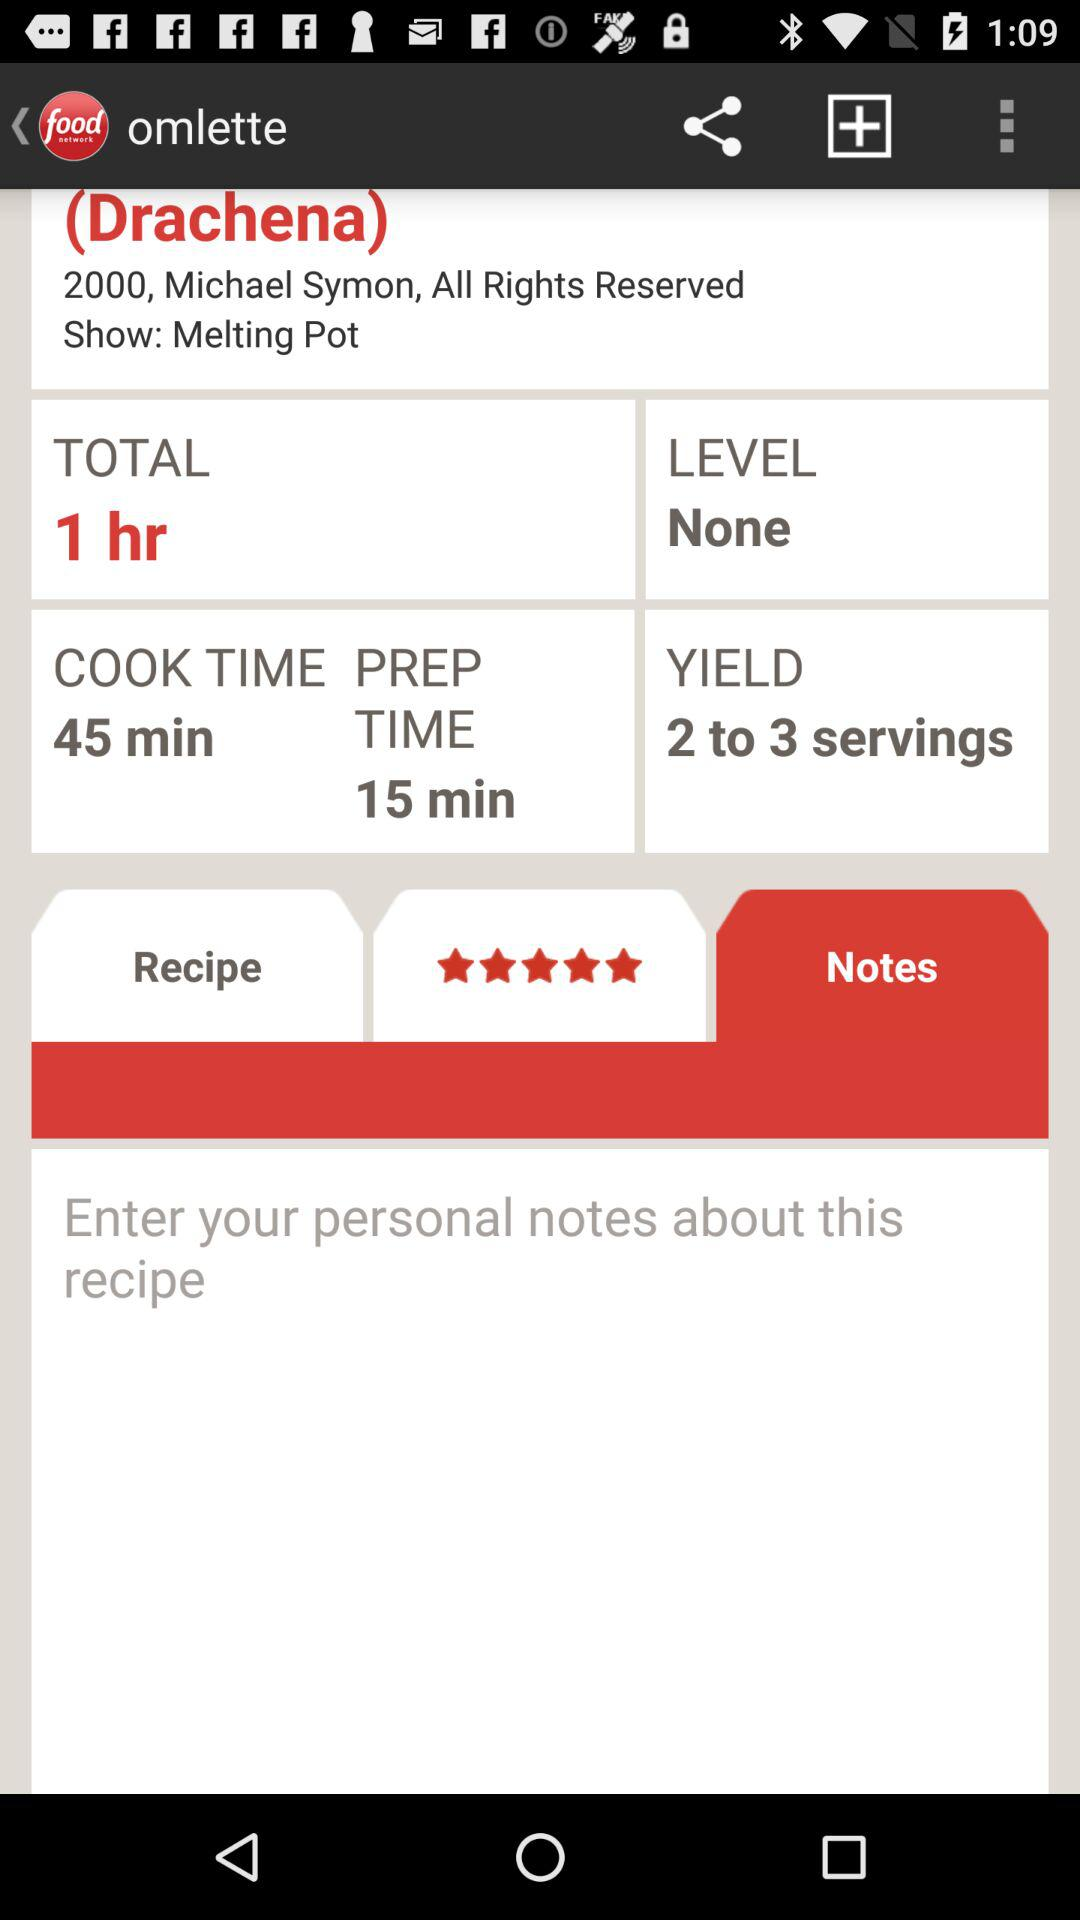How many rights are reserved?
When the provided information is insufficient, respond with <no answer>. <no answer> 